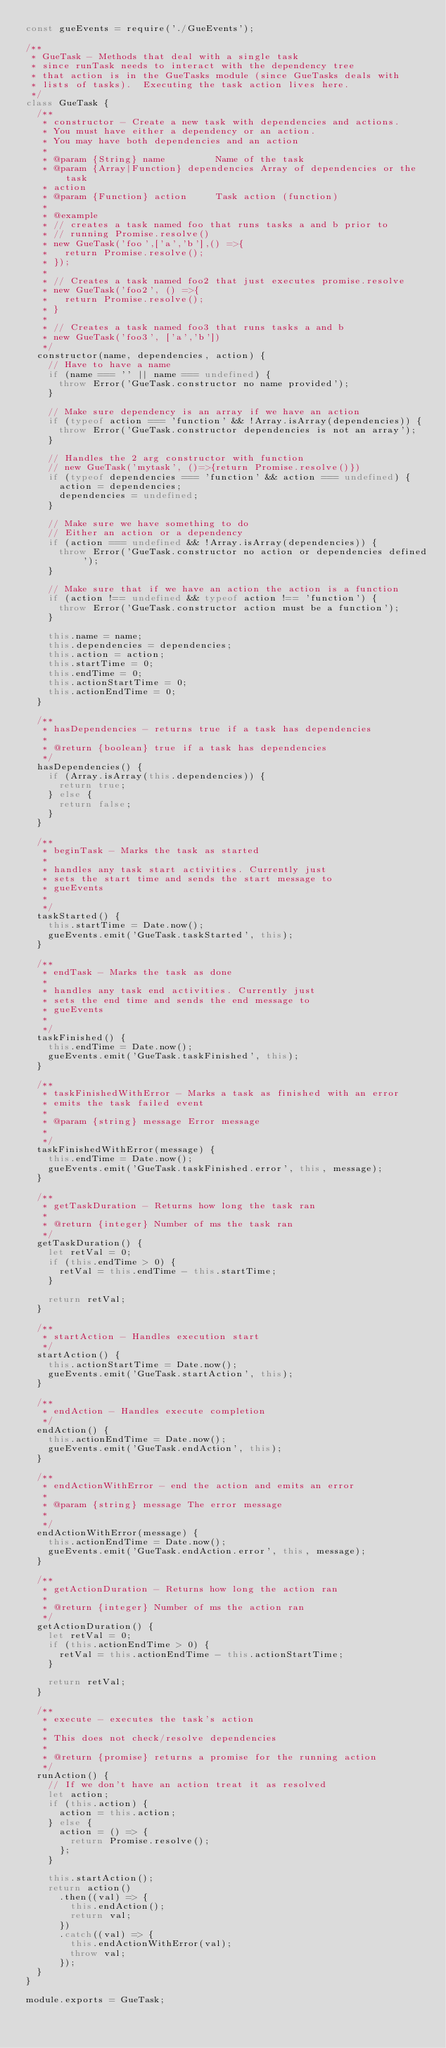Convert code to text. <code><loc_0><loc_0><loc_500><loc_500><_JavaScript_>const gueEvents = require('./GueEvents');

/**
 * GueTask - Methods that deal with a single task
 * since runTask needs to interact with the dependency tree
 * that action is in the GueTasks module (since GueTasks deals with
 * lists of tasks).  Executing the task action lives here.
 */
class GueTask {
  /**
   * constructor - Create a new task with dependencies and actions.
   * You must have either a dependency or an action.
   * You may have both dependencies and an action
   *
   * @param {String} name         Name of the task
   * @param {Array|Function} dependencies Array of dependencies or the task
   * action
   * @param {Function} action     Task action (function)
   *
   * @example
   * // creates a task named foo that runs tasks a and b prior to
   * // running Promise.resolve()
   * new GueTask('foo',['a','b'],() =>{
   *   return Promise.resolve();
   * });
   *
   * // Creates a task named foo2 that just executes promise.resolve
   * new GueTask('foo2', () =>{
   *   return Promise.resolve();
   * }
   *
   * // Creates a task named foo3 that runs tasks a and b
   * new GueTask('foo3', ['a','b'])
   */
  constructor(name, dependencies, action) {
    // Have to have a name
    if (name === '' || name === undefined) {
      throw Error('GueTask.constructor no name provided');
    }

    // Make sure dependency is an array if we have an action
    if (typeof action === 'function' && !Array.isArray(dependencies)) {
      throw Error('GueTask.constructor dependencies is not an array');
    }

    // Handles the 2 arg constructor with function
    // new GueTask('mytask', ()=>{return Promise.resolve()})
    if (typeof dependencies === 'function' && action === undefined) {
      action = dependencies;
      dependencies = undefined;
    }

    // Make sure we have something to do
    // Either an action or a dependency
    if (action === undefined && !Array.isArray(dependencies)) {
      throw Error('GueTask.constructor no action or dependencies defined');
    }

    // Make sure that if we have an action the action is a function
    if (action !== undefined && typeof action !== 'function') {
      throw Error('GueTask.constructor action must be a function');
    }

    this.name = name;
    this.dependencies = dependencies;
    this.action = action;
    this.startTime = 0;
    this.endTime = 0;
    this.actionStartTime = 0;
    this.actionEndTime = 0;
  }

  /**
   * hasDependencies - returns true if a task has dependencies
   *
   * @return {boolean} true if a task has dependencies
   */
  hasDependencies() {
    if (Array.isArray(this.dependencies)) {
      return true;
    } else {
      return false;
    }
  }

  /**
   * beginTask - Marks the task as started
   *
   * handles any task start activities. Currently just
   * sets the start time and sends the start message to
   * gueEvents
   *
   */
  taskStarted() {
    this.startTime = Date.now();
    gueEvents.emit('GueTask.taskStarted', this);
  }

  /**
   * endTask - Marks the task as done
   *
   * handles any task end activities. Currently just
   * sets the end time and sends the end message to
   * gueEvents
   *
   */
  taskFinished() {
    this.endTime = Date.now();
    gueEvents.emit('GueTask.taskFinished', this);
  }

  /**
   * taskFinishedWithError - Marks a task as finished with an error
   * emits the task failed event
   *
   * @param {string} message Error message
   *
   */
  taskFinishedWithError(message) {
    this.endTime = Date.now();
    gueEvents.emit('GueTask.taskFinished.error', this, message);
  }

  /**
   * getTaskDuration - Returns how long the task ran
   *
   * @return {integer} Number of ms the task ran
   */
  getTaskDuration() {
    let retVal = 0;
    if (this.endTime > 0) {
      retVal = this.endTime - this.startTime;
    }

    return retVal;
  }

  /**
   * startAction - Handles execution start
   */
  startAction() {
    this.actionStartTime = Date.now();
    gueEvents.emit('GueTask.startAction', this);
  }

  /**
   * endAction - Handles execute completion
   */
  endAction() {
    this.actionEndTime = Date.now();
    gueEvents.emit('GueTask.endAction', this);
  }

  /**
   * endActionWithError - end the action and emits an error
   *
   * @param {string} message The error message
   *
   */
  endActionWithError(message) {
    this.actionEndTime = Date.now();
    gueEvents.emit('GueTask.endAction.error', this, message);
  }

  /**
   * getActionDuration - Returns how long the action ran
   *
   * @return {integer} Number of ms the action ran
   */
  getActionDuration() {
    let retVal = 0;
    if (this.actionEndTime > 0) {
      retVal = this.actionEndTime - this.actionStartTime;
    }

    return retVal;
  }

  /**
   * execute - executes the task's action
   *
   * This does not check/resolve dependencies
   *
   * @return {promise} returns a promise for the running action
   */
  runAction() {
    // If we don't have an action treat it as resolved
    let action;
    if (this.action) {
      action = this.action;
    } else {
      action = () => {
        return Promise.resolve();
      };
    }

    this.startAction();
    return action()
      .then((val) => {
        this.endAction();
        return val;
      })
      .catch((val) => {
        this.endActionWithError(val);
        throw val;
      });
  }
}

module.exports = GueTask;
</code> 